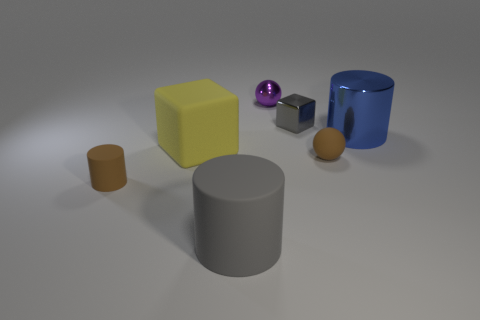There is a small matte sphere; is it the same color as the cylinder left of the big yellow block?
Your response must be concise. Yes. What shape is the rubber thing that is both in front of the brown matte sphere and to the right of the tiny cylinder?
Offer a very short reply. Cylinder. The large cylinder in front of the cylinder that is left of the cylinder in front of the small cylinder is made of what material?
Your response must be concise. Rubber. Are there more shiny things that are in front of the gray metal block than yellow objects that are right of the big rubber cube?
Provide a succinct answer. Yes. What number of gray cylinders have the same material as the yellow cube?
Provide a succinct answer. 1. There is a large rubber thing that is in front of the tiny brown cylinder; is its shape the same as the small brown object on the left side of the yellow matte object?
Offer a very short reply. Yes. There is a cylinder on the right side of the gray cylinder; what color is it?
Offer a terse response. Blue. Are there any other yellow things of the same shape as the yellow object?
Offer a terse response. No. What is the small purple sphere made of?
Your answer should be compact. Metal. How big is the thing that is both in front of the big yellow matte block and to the right of the tiny gray cube?
Give a very brief answer. Small. 